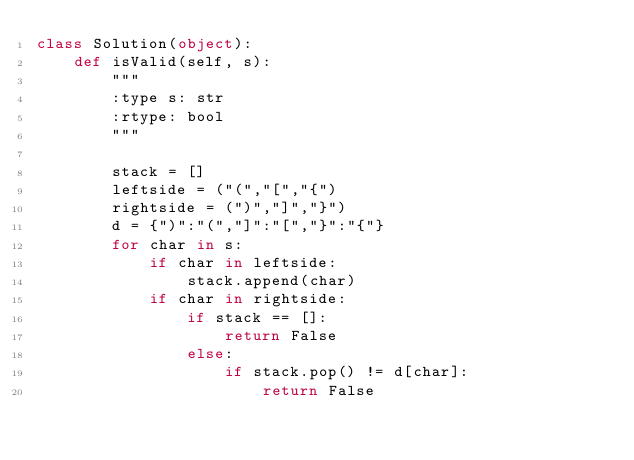<code> <loc_0><loc_0><loc_500><loc_500><_Python_>class Solution(object):
    def isValid(self, s):
        """
        :type s: str
        :rtype: bool
        """

        stack = []
        leftside = ("(","[","{")
        rightside = (")","]","}")
        d = {")":"(","]":"[","}":"{"}
        for char in s:
            if char in leftside:
                stack.append(char)
            if char in rightside:
                if stack == []:
                    return False
                else:
                    if stack.pop() != d[char]:
                        return False</code> 